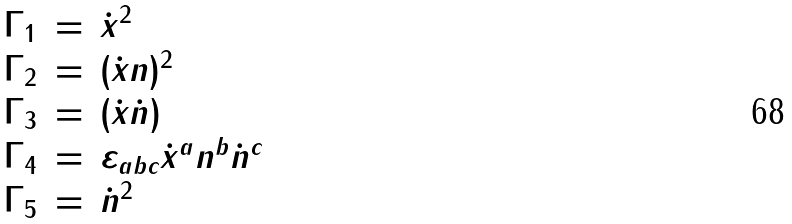<formula> <loc_0><loc_0><loc_500><loc_500>\begin{array} { r c l } \Gamma _ { 1 } & = & \dot { x } ^ { 2 } \\ \Gamma _ { 2 } & = & ( \dot { x } n ) ^ { 2 } \\ \Gamma _ { 3 } & = & ( \dot { x } \dot { n } ) \\ \Gamma _ { 4 } & = & \varepsilon _ { a b c } \dot { x } ^ { a } n ^ { b } \dot { n } ^ { c } \\ \Gamma _ { 5 } & = & \dot { n } ^ { 2 } \end{array}</formula> 